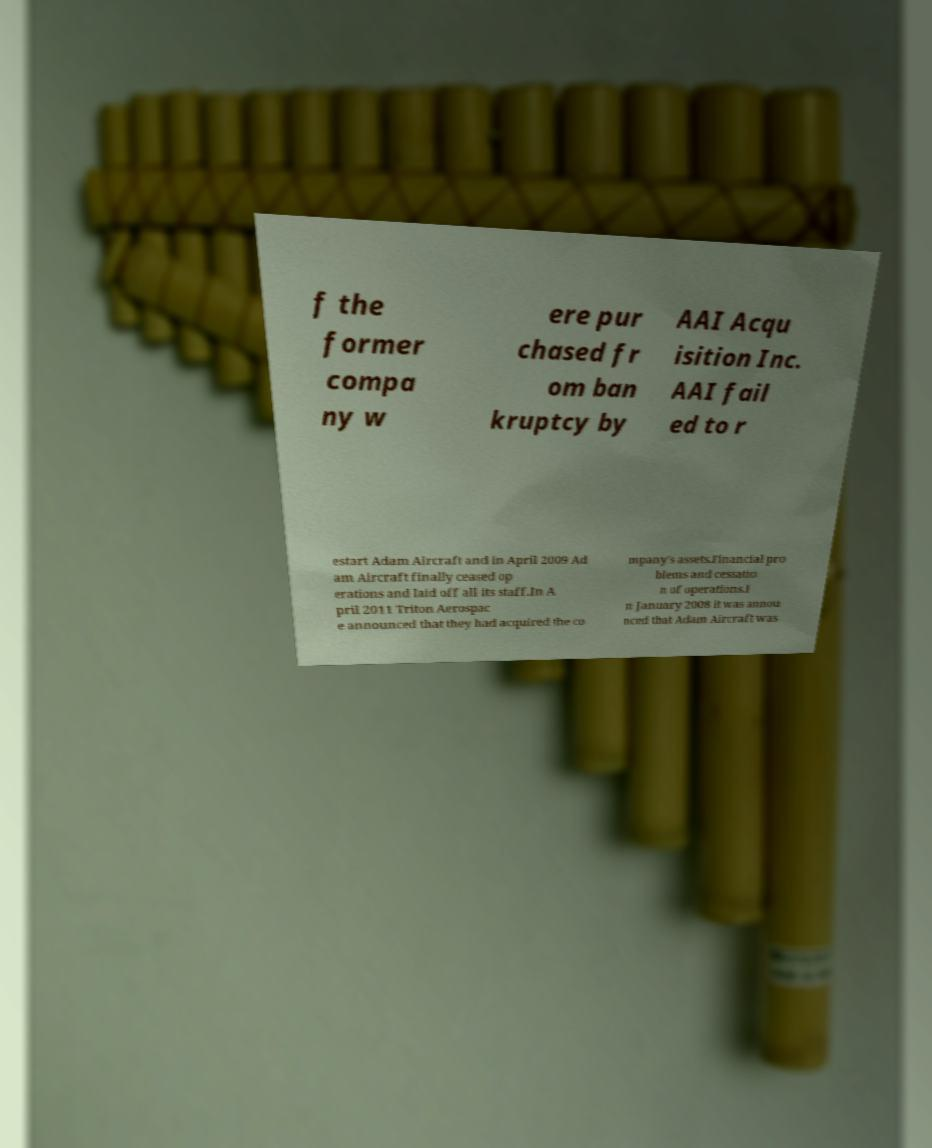There's text embedded in this image that I need extracted. Can you transcribe it verbatim? f the former compa ny w ere pur chased fr om ban kruptcy by AAI Acqu isition Inc. AAI fail ed to r estart Adam Aircraft and in April 2009 Ad am Aircraft finally ceased op erations and laid off all its staff.In A pril 2011 Triton Aerospac e announced that they had acquired the co mpany's assets.Financial pro blems and cessatio n of operations.I n January 2008 it was annou nced that Adam Aircraft was 